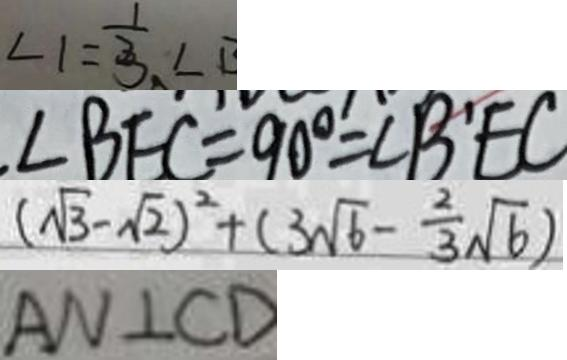<formula> <loc_0><loc_0><loc_500><loc_500>\angle 1 = \frac { 1 } { 3 } \angle B 
 \angle B E C = 9 0 ^ { \circ } = \angle B ^ { \prime } E C 
 ( \sqrt { 3 } - \sqrt { 2 } ) ^ { 2 } + ( 3 \sqrt { 6 } - \frac { 2 } { 3 } \sqrt { 6 } ) 
 A N \bot C D</formula> 